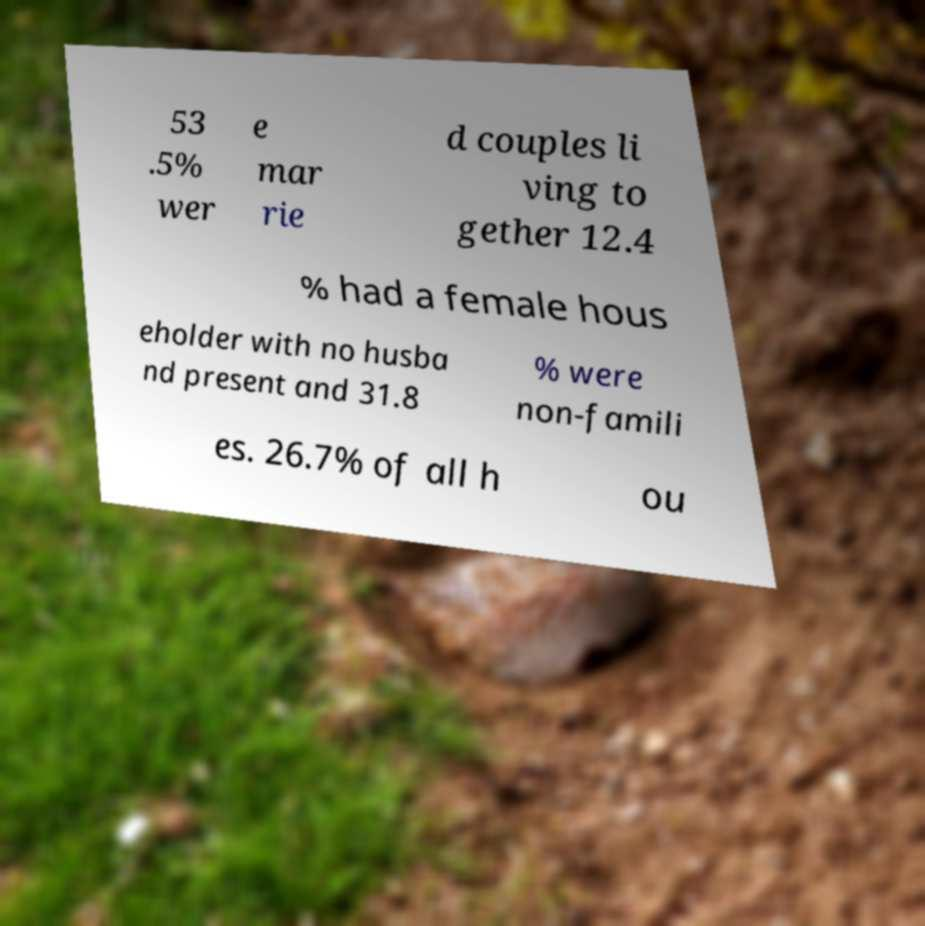I need the written content from this picture converted into text. Can you do that? 53 .5% wer e mar rie d couples li ving to gether 12.4 % had a female hous eholder with no husba nd present and 31.8 % were non-famili es. 26.7% of all h ou 